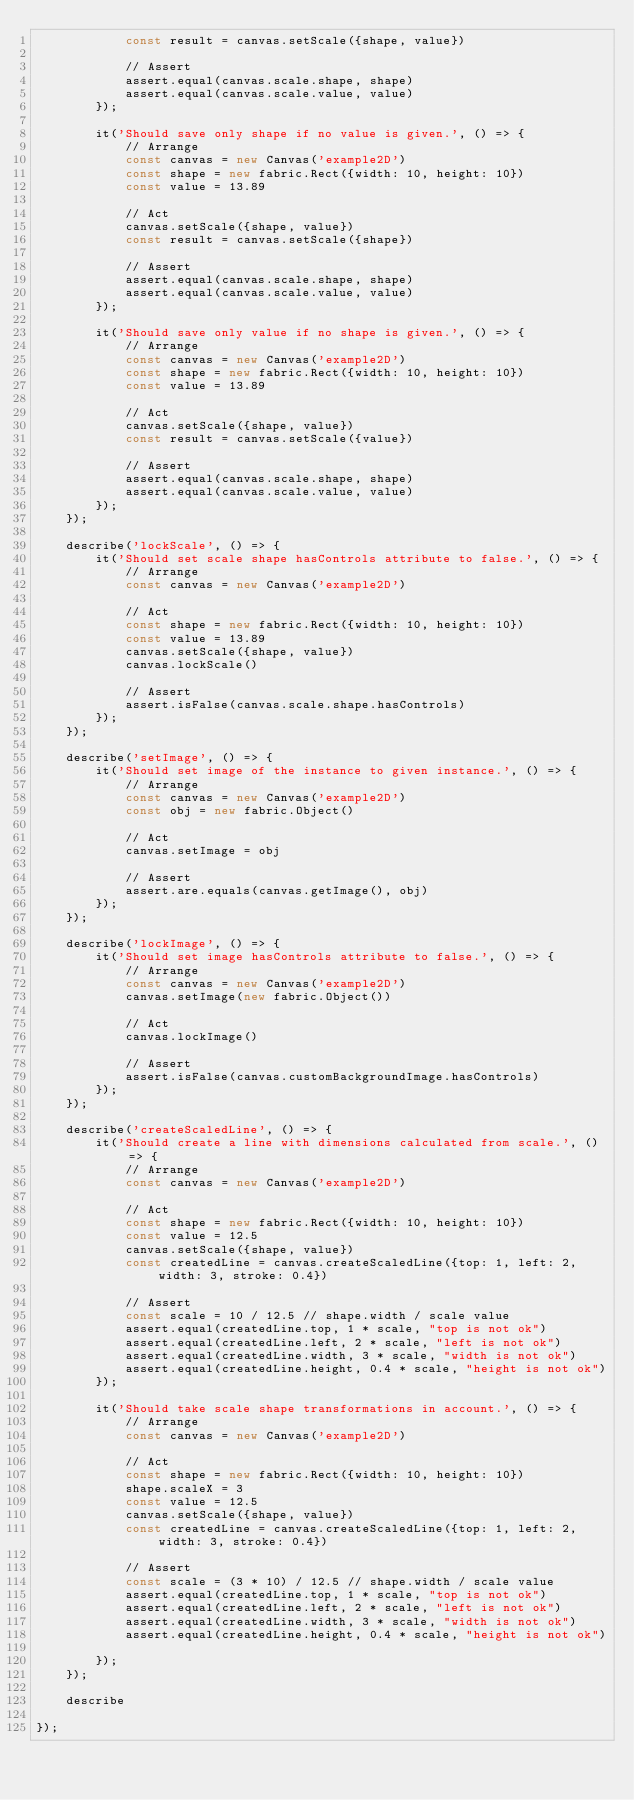<code> <loc_0><loc_0><loc_500><loc_500><_JavaScript_>            const result = canvas.setScale({shape, value})
        
            // Assert
            assert.equal(canvas.scale.shape, shape)
            assert.equal(canvas.scale.value, value)
        });

        it('Should save only shape if no value is given.', () => {
            // Arrange
            const canvas = new Canvas('example2D')
            const shape = new fabric.Rect({width: 10, height: 10})
            const value = 13.89
        
            // Act
            canvas.setScale({shape, value})
            const result = canvas.setScale({shape})
        
            // Assert
            assert.equal(canvas.scale.shape, shape)
            assert.equal(canvas.scale.value, value)
        });

        it('Should save only value if no shape is given.', () => {
            // Arrange
            const canvas = new Canvas('example2D')
            const shape = new fabric.Rect({width: 10, height: 10})
            const value = 13.89
        
            // Act
            canvas.setScale({shape, value})
            const result = canvas.setScale({value})
        
            // Assert
            assert.equal(canvas.scale.shape, shape)
            assert.equal(canvas.scale.value, value)
        });
    });

    describe('lockScale', () => {
        it('Should set scale shape hasControls attribute to false.', () => {
            // Arrange
            const canvas = new Canvas('example2D')
        
            // Act
            const shape = new fabric.Rect({width: 10, height: 10})
            const value = 13.89
            canvas.setScale({shape, value})
            canvas.lockScale()
        
            // Assert
            assert.isFalse(canvas.scale.shape.hasControls)
        });
    });

    describe('setImage', () => {
        it('Should set image of the instance to given instance.', () => {
            // Arrange
            const canvas = new Canvas('example2D')
            const obj = new fabric.Object()
        
            // Act
            canvas.setImage = obj
        
            // Assert
            assert.are.equals(canvas.getImage(), obj)
        });
    });

    describe('lockImage', () => {
        it('Should set image hasControls attribute to false.', () => {
            // Arrange
            const canvas = new Canvas('example2D')
            canvas.setImage(new fabric.Object())
        
            // Act
            canvas.lockImage()
        
            // Assert
            assert.isFalse(canvas.customBackgroundImage.hasControls)
        });
    });

    describe('createScaledLine', () => {
        it('Should create a line with dimensions calculated from scale.', () => {
            // Arrange
            const canvas = new Canvas('example2D')
        
            // Act
            const shape = new fabric.Rect({width: 10, height: 10})
            const value = 12.5
            canvas.setScale({shape, value})
            const createdLine = canvas.createScaledLine({top: 1, left: 2, width: 3, stroke: 0.4})
        
            // Assert
            const scale = 10 / 12.5 // shape.width / scale value
            assert.equal(createdLine.top, 1 * scale, "top is not ok")
            assert.equal(createdLine.left, 2 * scale, "left is not ok")
            assert.equal(createdLine.width, 3 * scale, "width is not ok")
            assert.equal(createdLine.height, 0.4 * scale, "height is not ok")
        });

        it('Should take scale shape transformations in account.', () => {
            // Arrange
            const canvas = new Canvas('example2D')
        
            // Act
            const shape = new fabric.Rect({width: 10, height: 10})
            shape.scaleX = 3
            const value = 12.5
            canvas.setScale({shape, value})
            const createdLine = canvas.createScaledLine({top: 1, left: 2, width: 3, stroke: 0.4})
        
            // Assert
            const scale = (3 * 10) / 12.5 // shape.width / scale value
            assert.equal(createdLine.top, 1 * scale, "top is not ok")
            assert.equal(createdLine.left, 2 * scale, "left is not ok")
            assert.equal(createdLine.width, 3 * scale, "width is not ok")
            assert.equal(createdLine.height, 0.4 * scale, "height is not ok")

        });
    });

    describe

});
</code> 